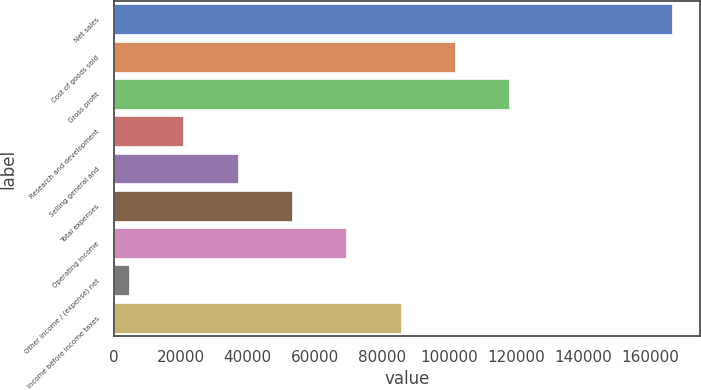Convert chart. <chart><loc_0><loc_0><loc_500><loc_500><bar_chart><fcel>Net sales<fcel>Cost of goods sold<fcel>Gross profit<fcel>Research and development<fcel>Selling general and<fcel>Total expenses<fcel>Operating income<fcel>Other income / (expense) net<fcel>Income before income taxes<nl><fcel>166639<fcel>101809<fcel>118016<fcel>20770.6<fcel>36978.2<fcel>53185.8<fcel>69393.4<fcel>4563<fcel>85601<nl></chart> 